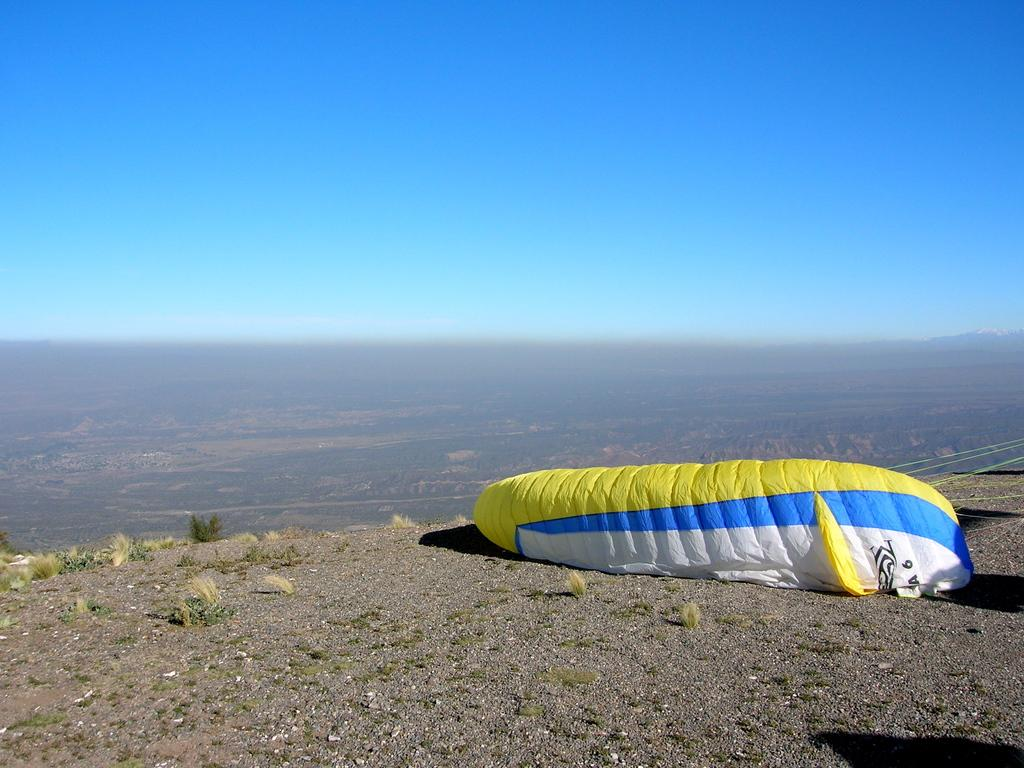What is the vantage point of the image? The image is taken from the top of a mountain. What can be seen on the ground in the image? There is a parachute on the ground. What type of vegetation is visible in the background? There is greenery visible in the background. What color is the sky in the background? The sky is blue in the background. What type of popcorn is being served at the treatment center in the image? There is no treatment center or popcorn present in the image. 